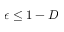Convert formula to latex. <formula><loc_0><loc_0><loc_500><loc_500>\epsilon \leq 1 - D</formula> 